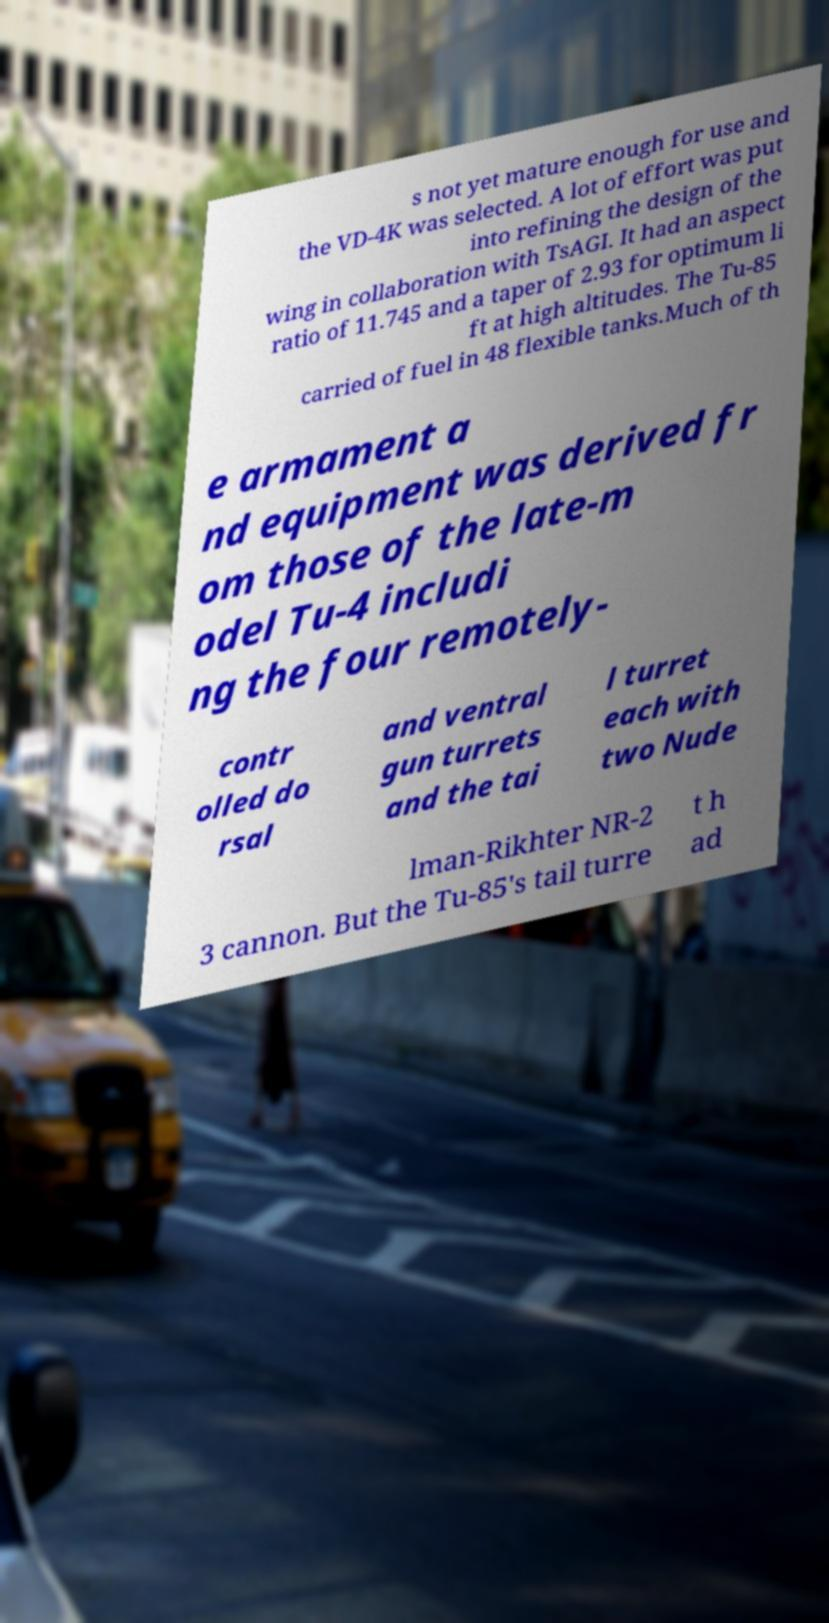Please identify and transcribe the text found in this image. s not yet mature enough for use and the VD-4K was selected. A lot of effort was put into refining the design of the wing in collaboration with TsAGI. It had an aspect ratio of 11.745 and a taper of 2.93 for optimum li ft at high altitudes. The Tu-85 carried of fuel in 48 flexible tanks.Much of th e armament a nd equipment was derived fr om those of the late-m odel Tu-4 includi ng the four remotely- contr olled do rsal and ventral gun turrets and the tai l turret each with two Nude lman-Rikhter NR-2 3 cannon. But the Tu-85's tail turre t h ad 